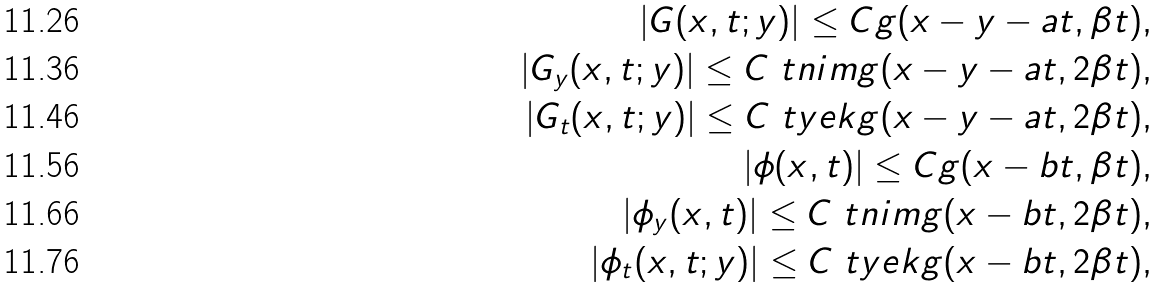<formula> <loc_0><loc_0><loc_500><loc_500>| G ( x , t ; y ) | \leq C g ( x - y - a t , \beta t ) , \\ | G _ { y } ( x , t ; y ) | \leq C \ t n i m g ( x - y - a t , 2 \beta t ) , \\ | G _ { t } ( x , t ; y ) | \leq C \ t y e k g ( x - y - a t , 2 \beta t ) , \\ | \phi ( x , t ) | \leq C g ( x - b t , \beta t ) , \\ | \phi _ { y } ( x , t ) | \leq C \ t n i m g ( x - b t , 2 \beta t ) , \\ | \phi _ { t } ( x , t ; y ) | \leq C \ t y e k g ( x - b t , 2 \beta t ) ,</formula> 